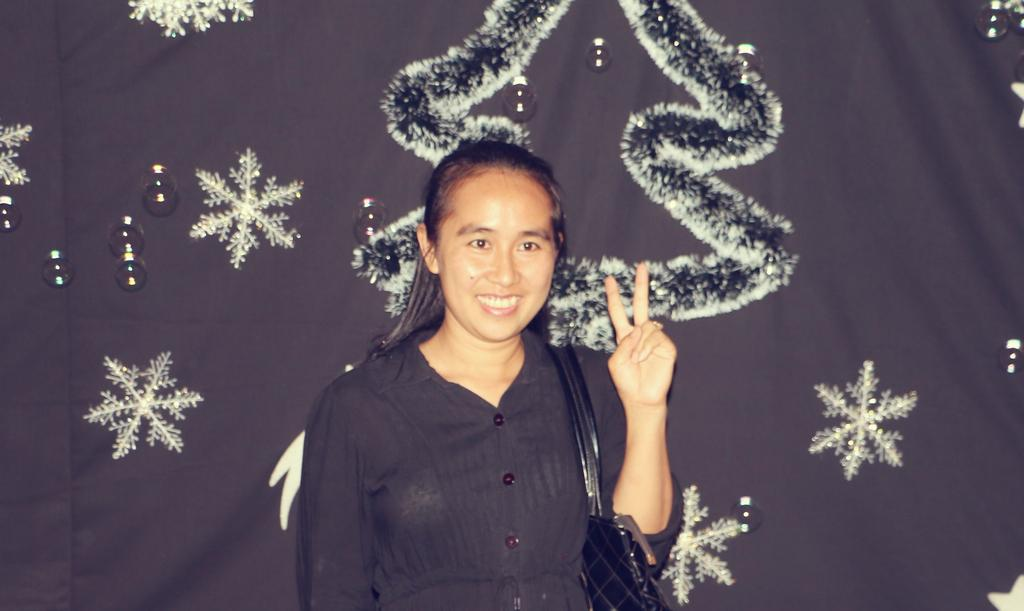What is the main subject of the image? There is a person in the image. What is the person carrying in the image? The person is carrying a bag. What else can be seen in the image besides the person? There are bubbles visible in the image. What is the color and design of the object in the background? There is a black colored object in the background, and it has some design on it. Can you describe the size of the giants in the image? There are no giants present in the image; it features a person carrying a bag and bubbles visible in the background. What type of bee can be seen interacting with the bubbles in the image? There is no bee present in the image; it only features a person, a bag, bubbles, and a black colored object with a design in the background. 